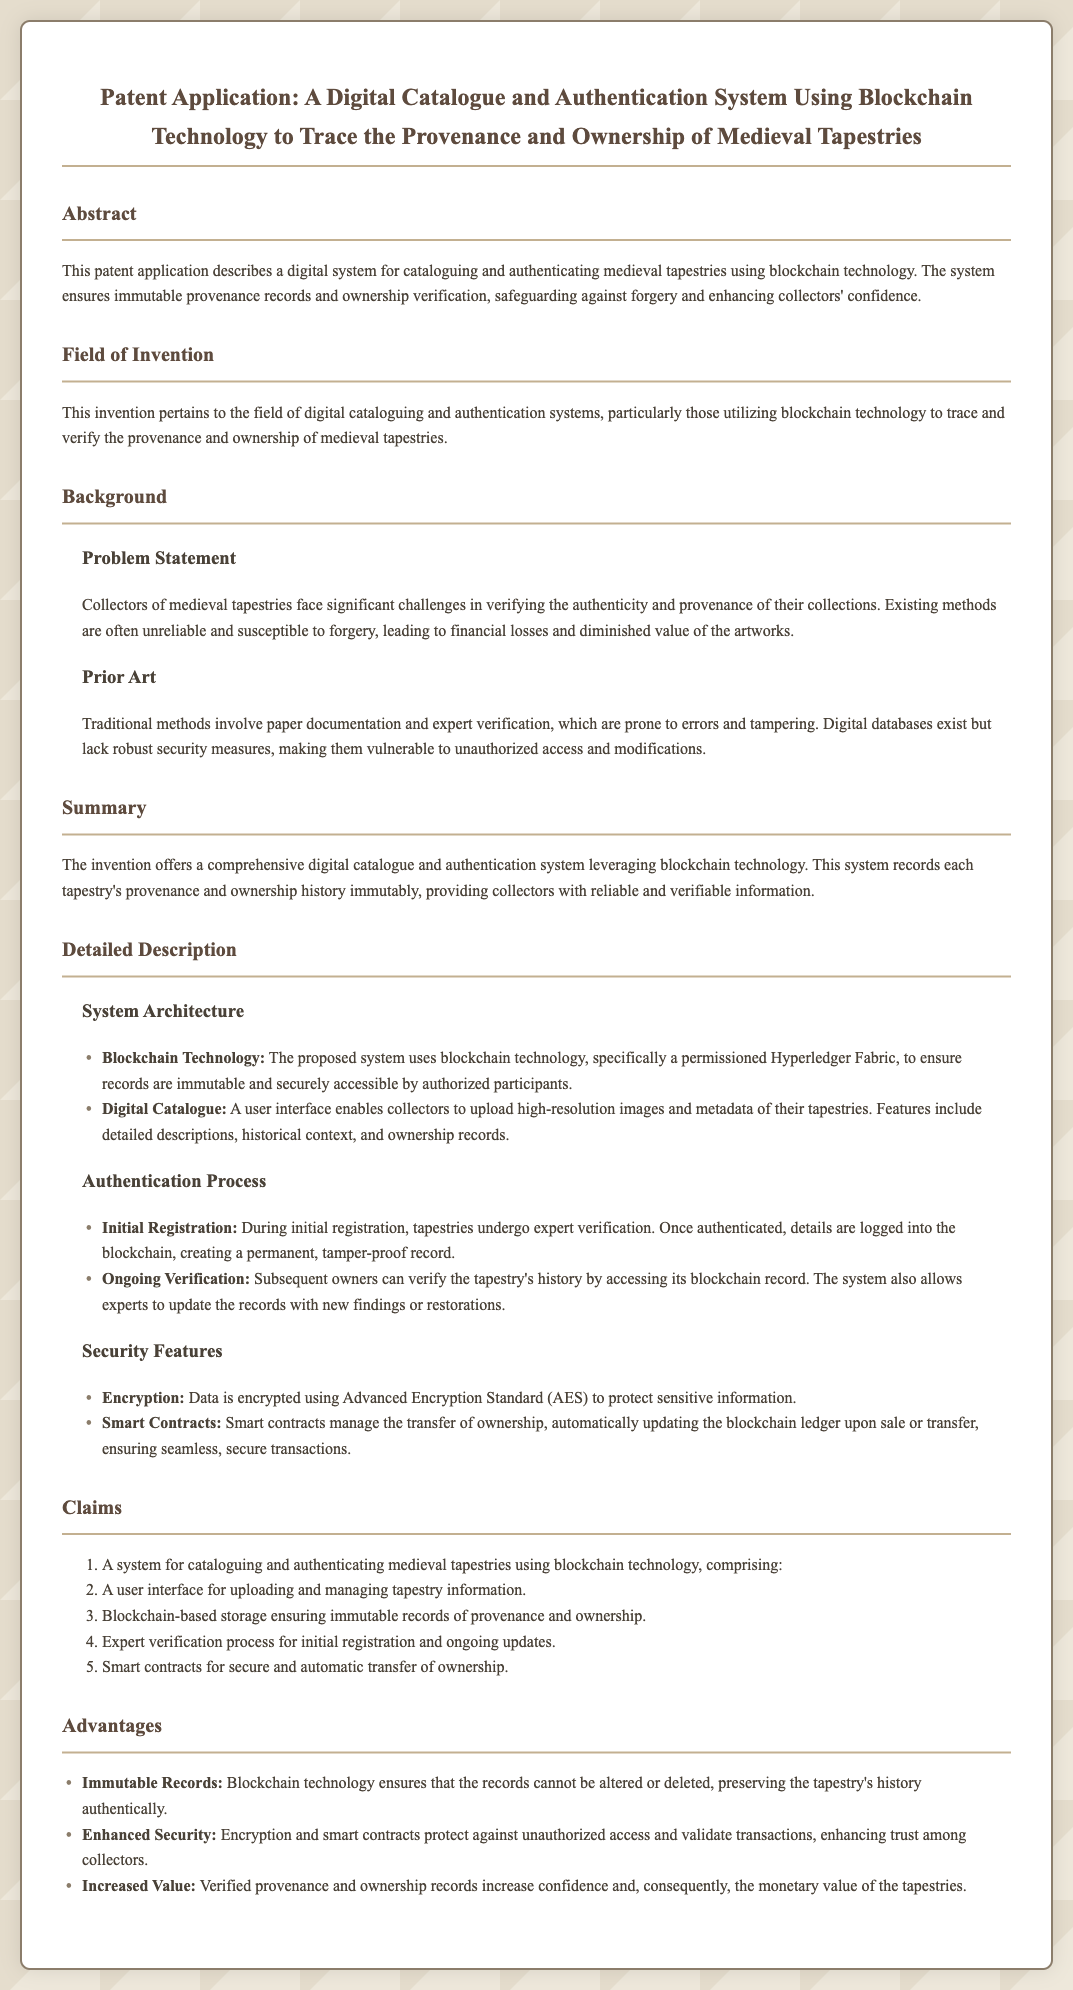What is the title of the patent application? The title of the patent application is stated at the top of the document.
Answer: A Digital Catalogue and Authentication System Using Blockchain Technology to Trace the Provenance and Ownership of Medieval Tapestries What technology does the system utilize? The document specifies the technology that the system leverages in its description.
Answer: Blockchain technology What is the primary problem addressed by the invention? The document outlines the main issue faced by collectors of medieval tapestries in the background section.
Answer: Verifying the authenticity and provenance What type of encryption is used to protect data? The document describes the specific encryption method used within the security features.
Answer: Advanced Encryption Standard (AES) What do smart contracts manage in the authentication system? The document explains the role of smart contracts in the detailed description section.
Answer: The transfer of ownership How many claims are listed in the document? The total number of claims can be found in the claims section of the document.
Answer: Five Why is the authentication system advantageous for collectors? The advantages section discusses the benefits of the system for collectors.
Answer: Increases confidence What is the user interface used for in the system? The document describes the purpose of the user interface in the system architecture.
Answer: Uploading and managing tapestry information What feature provides verifiable information about tapestries? The summary section highlights the primary feature that assures reliable information.
Answer: Immutable provenance records 